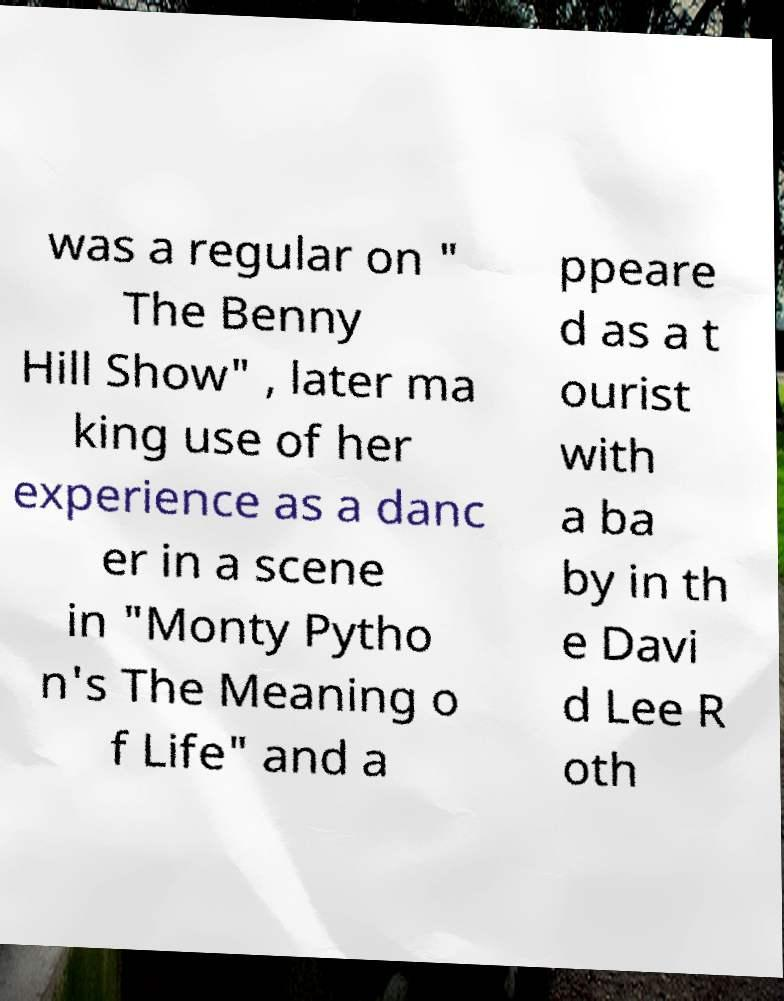Could you assist in decoding the text presented in this image and type it out clearly? was a regular on " The Benny Hill Show" , later ma king use of her experience as a danc er in a scene in "Monty Pytho n's The Meaning o f Life" and a ppeare d as a t ourist with a ba by in th e Davi d Lee R oth 